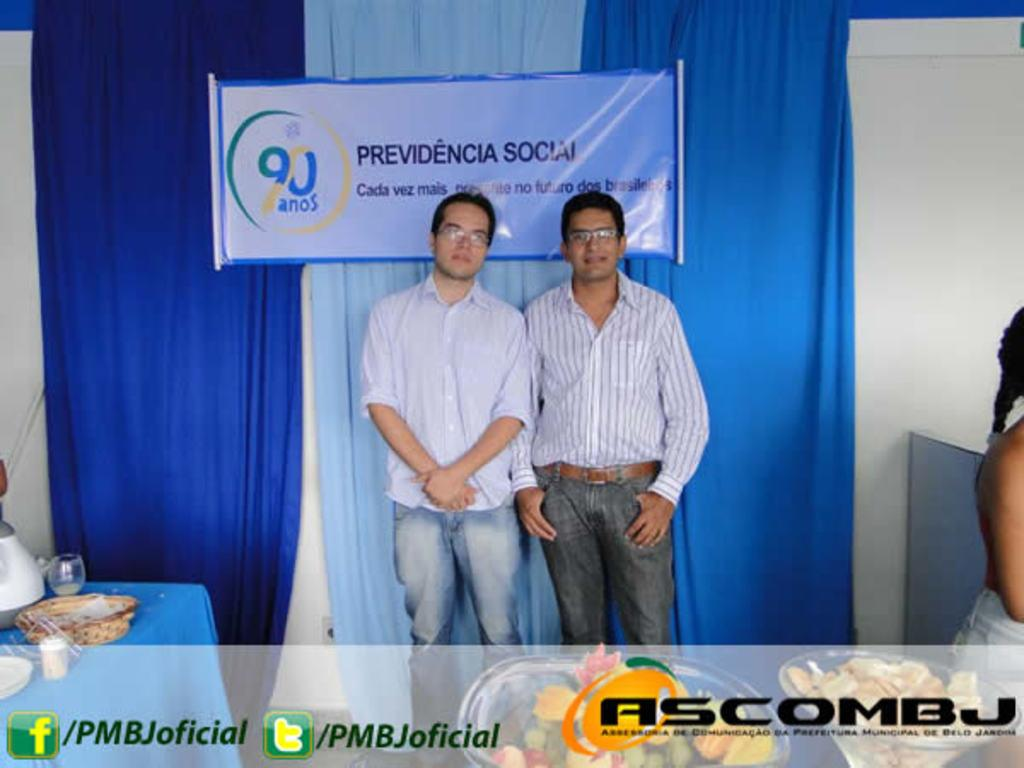How many people are present in the image? There are three people in the image. What else can be seen in the image besides the people? There are banners and curtains in the image. Where is the table located in the image? The table is on the left side of the image. What items are on the table? There are glasses and a pot on the table. What type of knife is being used to cut the substance on the table? There is no knife or substance present on the table in the image. 